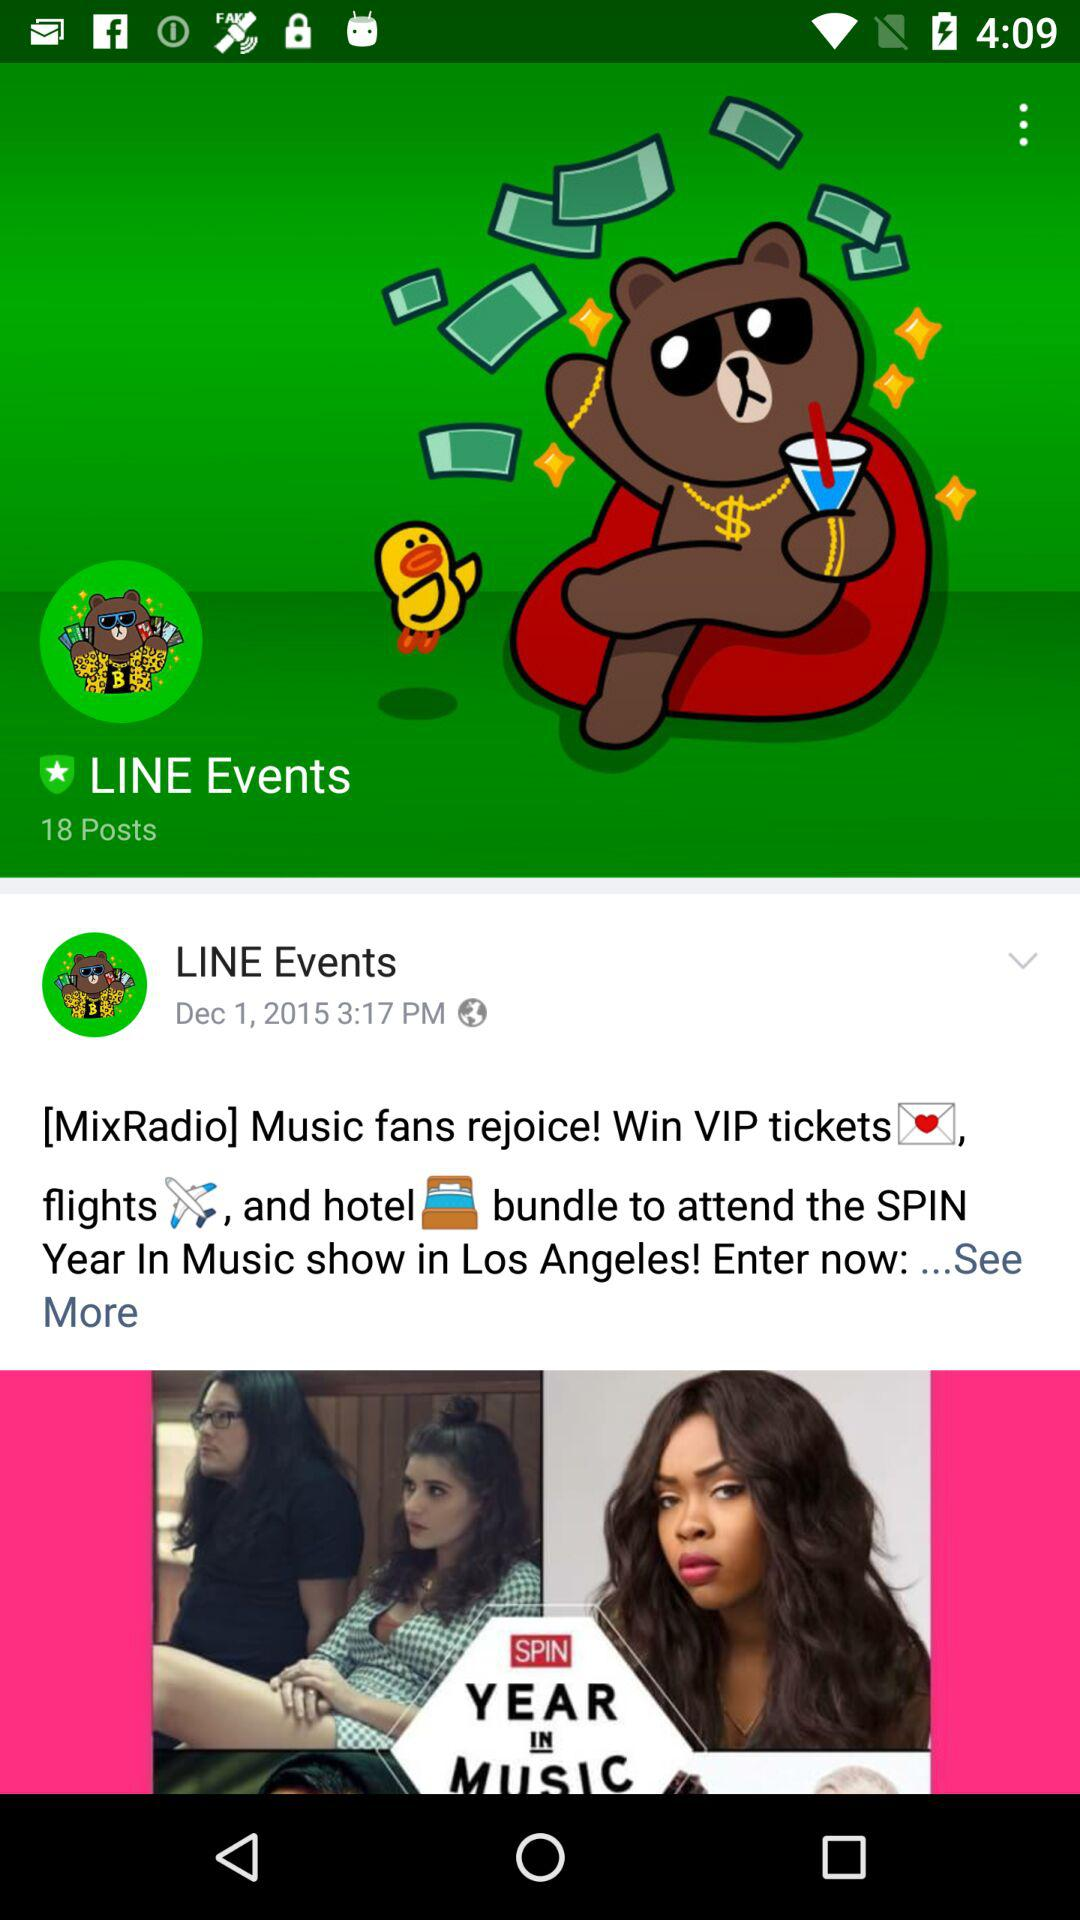When were LINE Events posted? The LINE Events were posted on December 1, 2015 at 3:17 PM. 